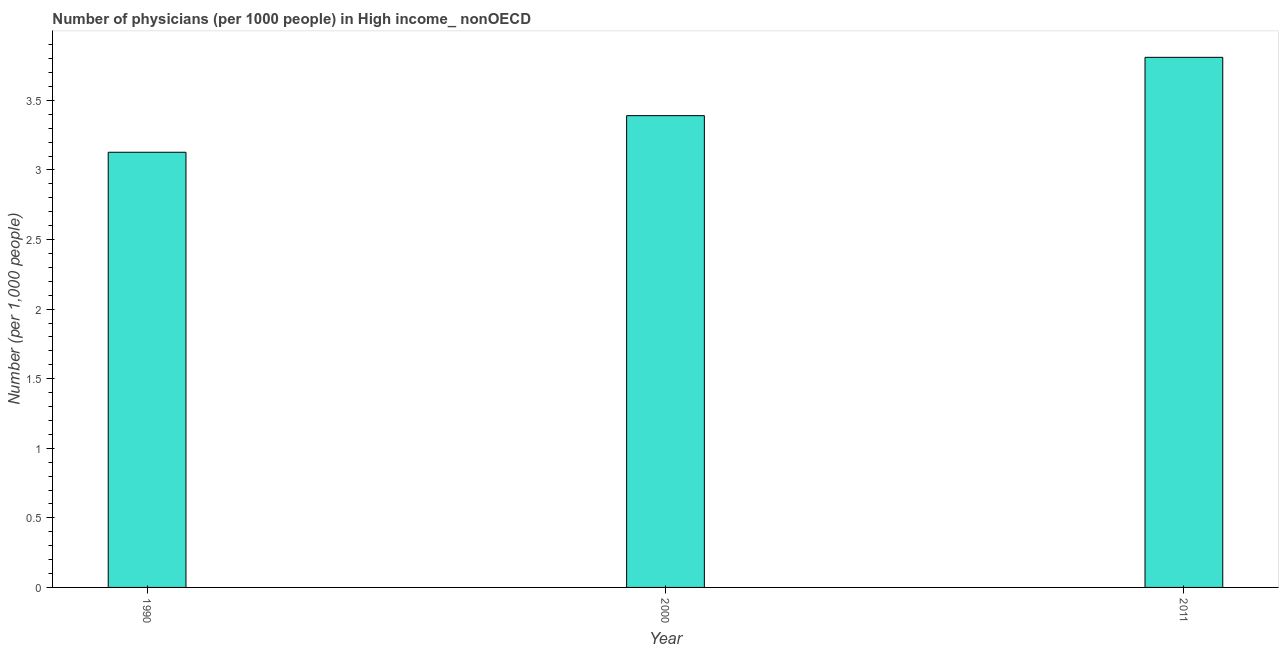Does the graph contain grids?
Provide a short and direct response. No. What is the title of the graph?
Provide a succinct answer. Number of physicians (per 1000 people) in High income_ nonOECD. What is the label or title of the X-axis?
Your answer should be very brief. Year. What is the label or title of the Y-axis?
Make the answer very short. Number (per 1,0 people). What is the number of physicians in 1990?
Your answer should be compact. 3.13. Across all years, what is the maximum number of physicians?
Ensure brevity in your answer.  3.81. Across all years, what is the minimum number of physicians?
Provide a short and direct response. 3.13. In which year was the number of physicians maximum?
Give a very brief answer. 2011. In which year was the number of physicians minimum?
Offer a very short reply. 1990. What is the sum of the number of physicians?
Ensure brevity in your answer.  10.33. What is the difference between the number of physicians in 1990 and 2011?
Give a very brief answer. -0.68. What is the average number of physicians per year?
Keep it short and to the point. 3.44. What is the median number of physicians?
Your answer should be compact. 3.39. In how many years, is the number of physicians greater than 1.7 ?
Your response must be concise. 3. Do a majority of the years between 2000 and 2011 (inclusive) have number of physicians greater than 3.2 ?
Offer a terse response. Yes. What is the ratio of the number of physicians in 1990 to that in 2000?
Offer a terse response. 0.92. Is the number of physicians in 2000 less than that in 2011?
Your answer should be very brief. Yes. What is the difference between the highest and the second highest number of physicians?
Your answer should be compact. 0.42. Is the sum of the number of physicians in 1990 and 2011 greater than the maximum number of physicians across all years?
Make the answer very short. Yes. What is the difference between the highest and the lowest number of physicians?
Give a very brief answer. 0.68. In how many years, is the number of physicians greater than the average number of physicians taken over all years?
Ensure brevity in your answer.  1. How many years are there in the graph?
Offer a very short reply. 3. Are the values on the major ticks of Y-axis written in scientific E-notation?
Your response must be concise. No. What is the Number (per 1,000 people) of 1990?
Keep it short and to the point. 3.13. What is the Number (per 1,000 people) in 2000?
Offer a very short reply. 3.39. What is the Number (per 1,000 people) in 2011?
Your response must be concise. 3.81. What is the difference between the Number (per 1,000 people) in 1990 and 2000?
Your answer should be very brief. -0.26. What is the difference between the Number (per 1,000 people) in 1990 and 2011?
Ensure brevity in your answer.  -0.68. What is the difference between the Number (per 1,000 people) in 2000 and 2011?
Your response must be concise. -0.42. What is the ratio of the Number (per 1,000 people) in 1990 to that in 2000?
Make the answer very short. 0.92. What is the ratio of the Number (per 1,000 people) in 1990 to that in 2011?
Give a very brief answer. 0.82. What is the ratio of the Number (per 1,000 people) in 2000 to that in 2011?
Provide a succinct answer. 0.89. 